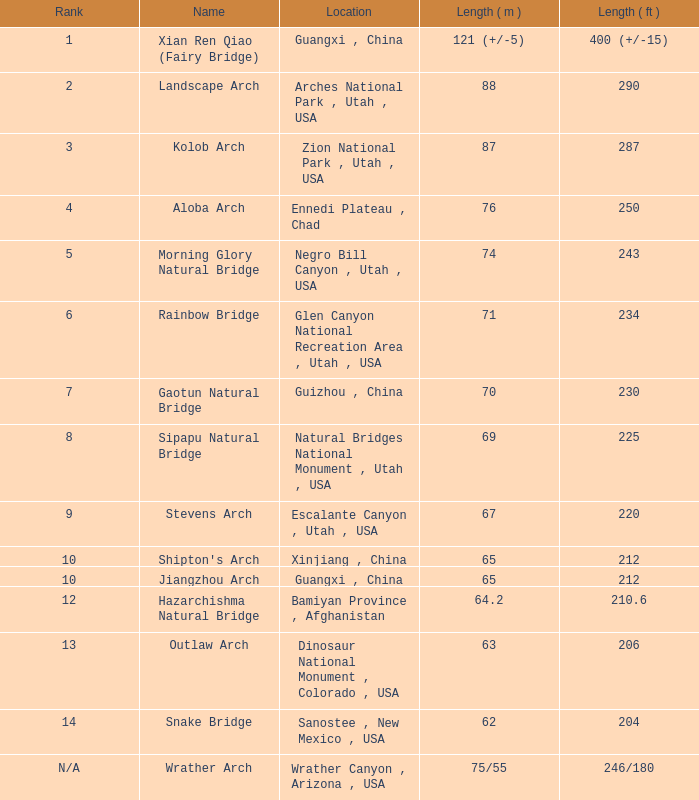What is the ranking of an arch with a 75/55 meters length? N/A. 